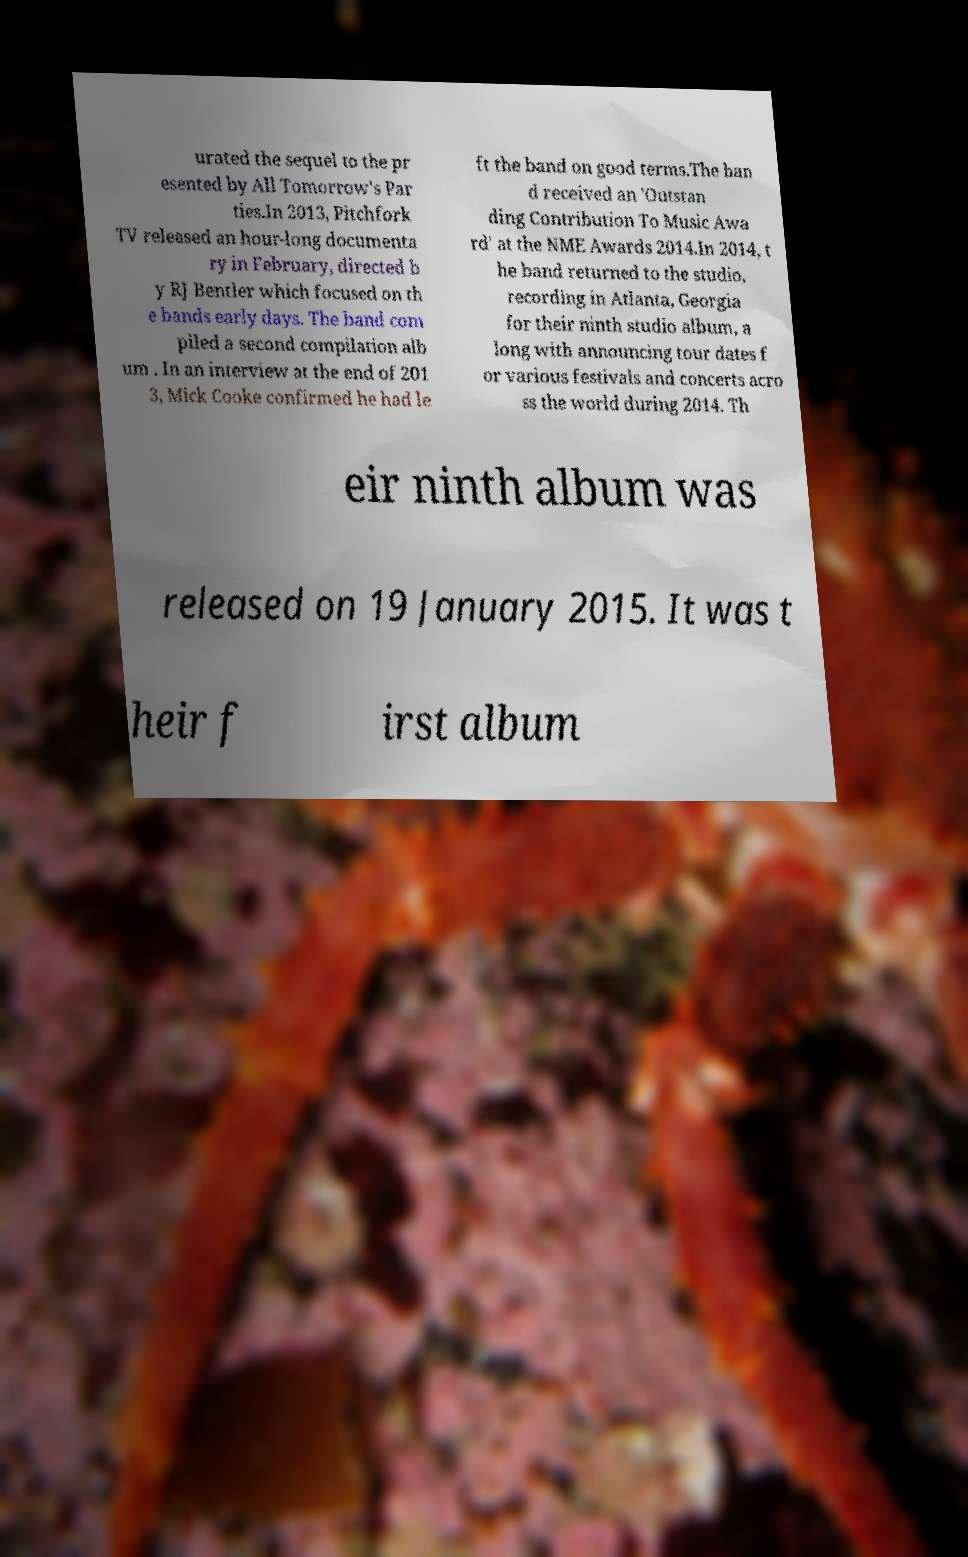Could you extract and type out the text from this image? urated the sequel to the pr esented by All Tomorrow's Par ties.In 2013, Pitchfork TV released an hour-long documenta ry in February, directed b y RJ Bentler which focused on th e bands early days. The band com piled a second compilation alb um . In an interview at the end of 201 3, Mick Cooke confirmed he had le ft the band on good terms.The ban d received an 'Outstan ding Contribution To Music Awa rd' at the NME Awards 2014.In 2014, t he band returned to the studio, recording in Atlanta, Georgia for their ninth studio album, a long with announcing tour dates f or various festivals and concerts acro ss the world during 2014. Th eir ninth album was released on 19 January 2015. It was t heir f irst album 